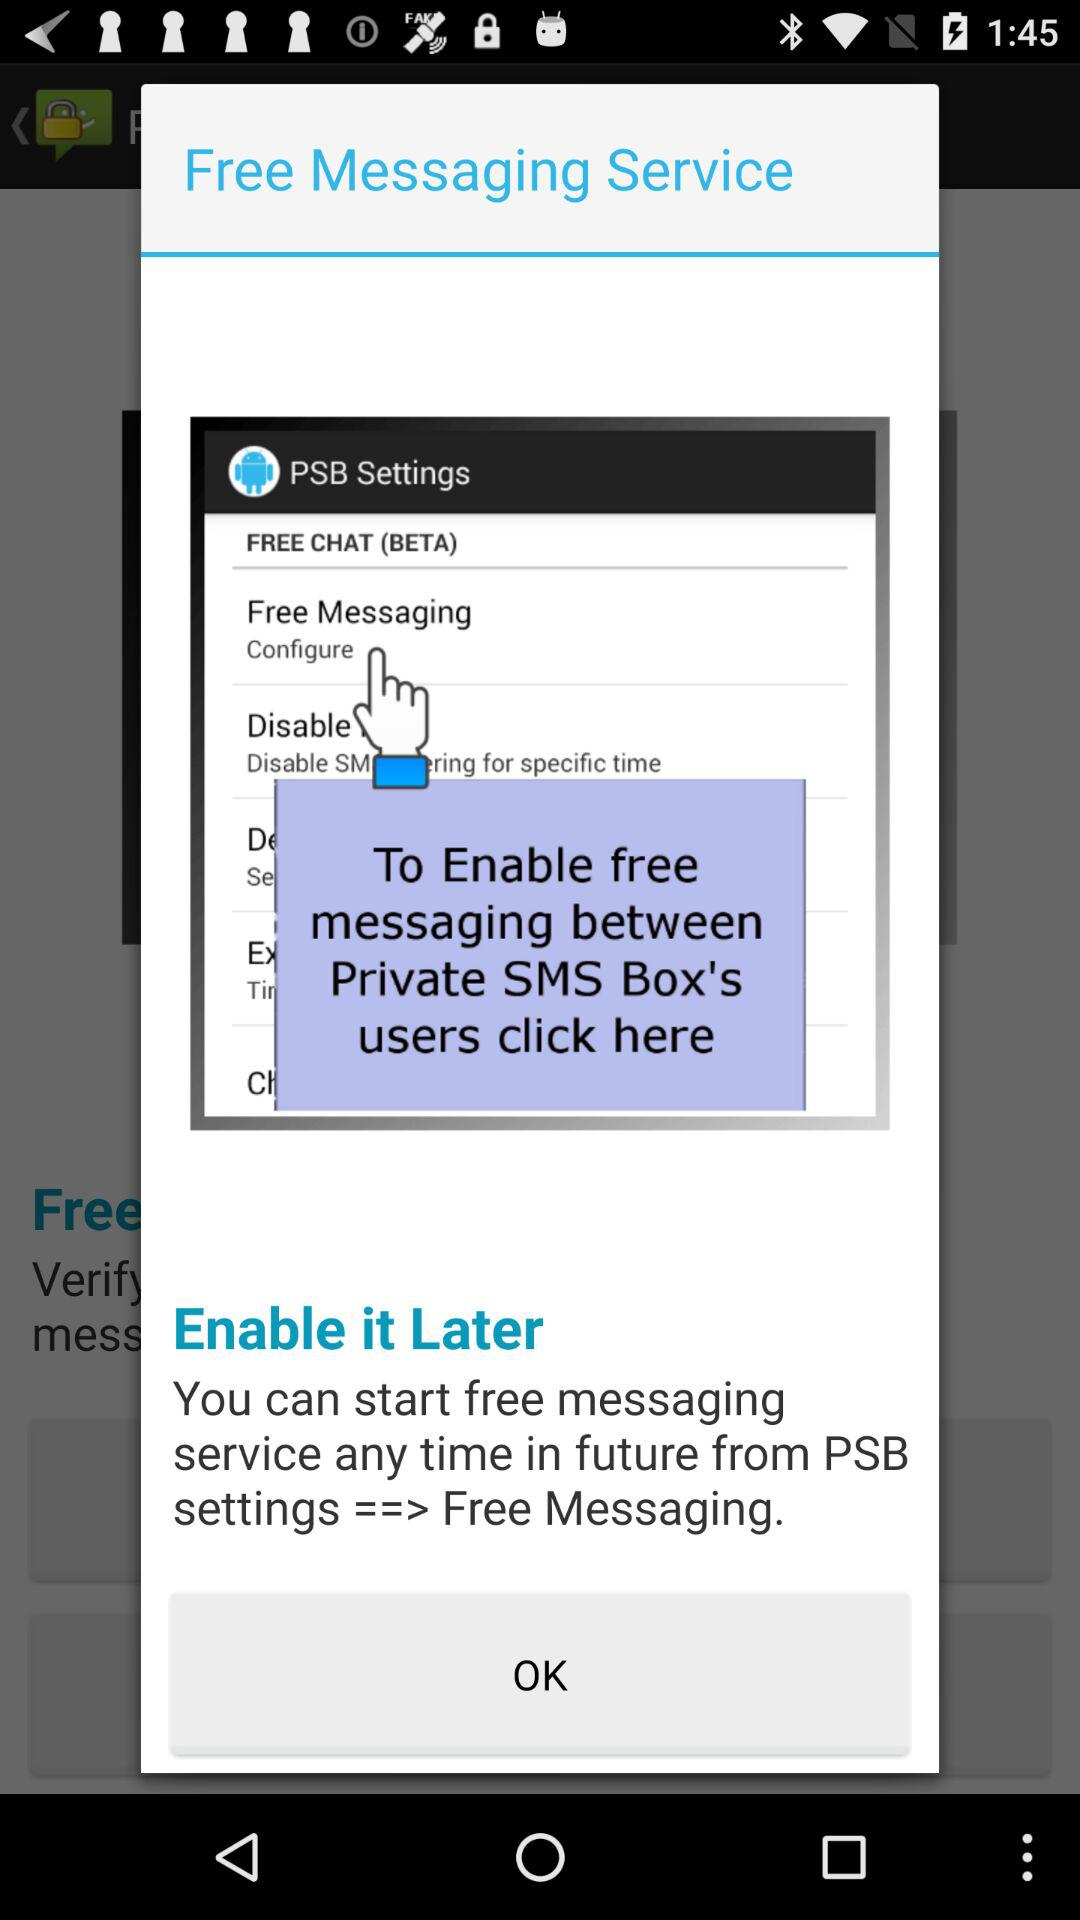At what time can we start free messaging service from PSB? You can start free messaging service any time in future from PSB. 